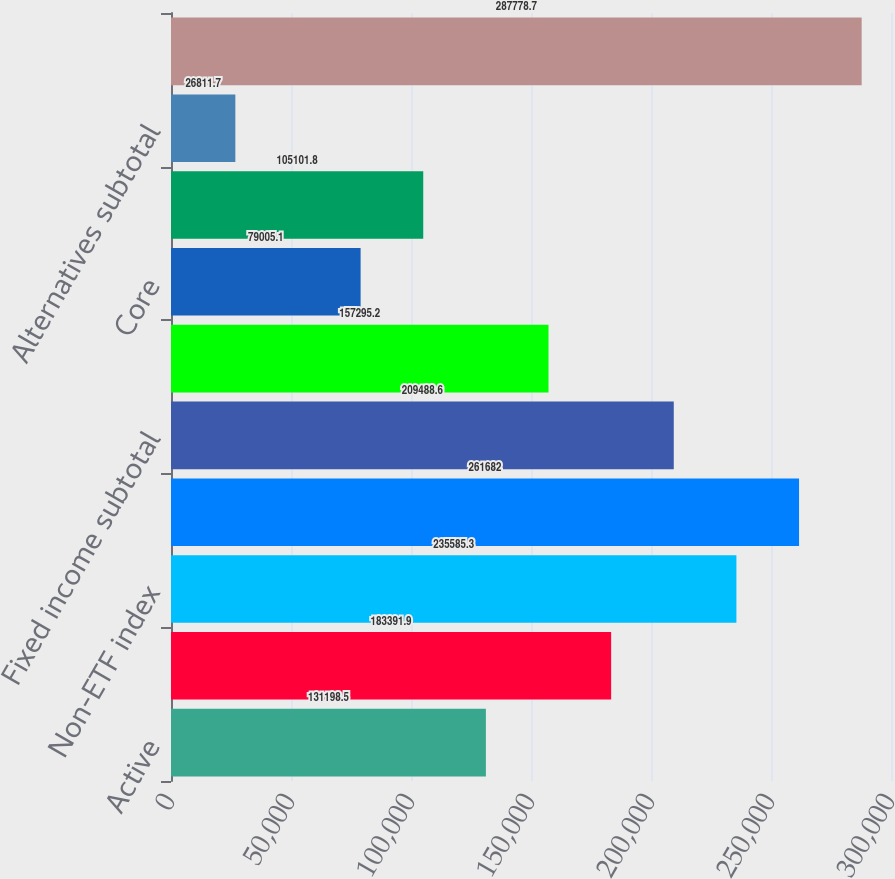<chart> <loc_0><loc_0><loc_500><loc_500><bar_chart><fcel>Active<fcel>iShares<fcel>Non-ETF index<fcel>Equity subtotal<fcel>Fixed income subtotal<fcel>Multi-asset class<fcel>Core<fcel>Currency and commodities<fcel>Alternatives subtotal<fcel>Long-term<nl><fcel>131198<fcel>183392<fcel>235585<fcel>261682<fcel>209489<fcel>157295<fcel>79005.1<fcel>105102<fcel>26811.7<fcel>287779<nl></chart> 